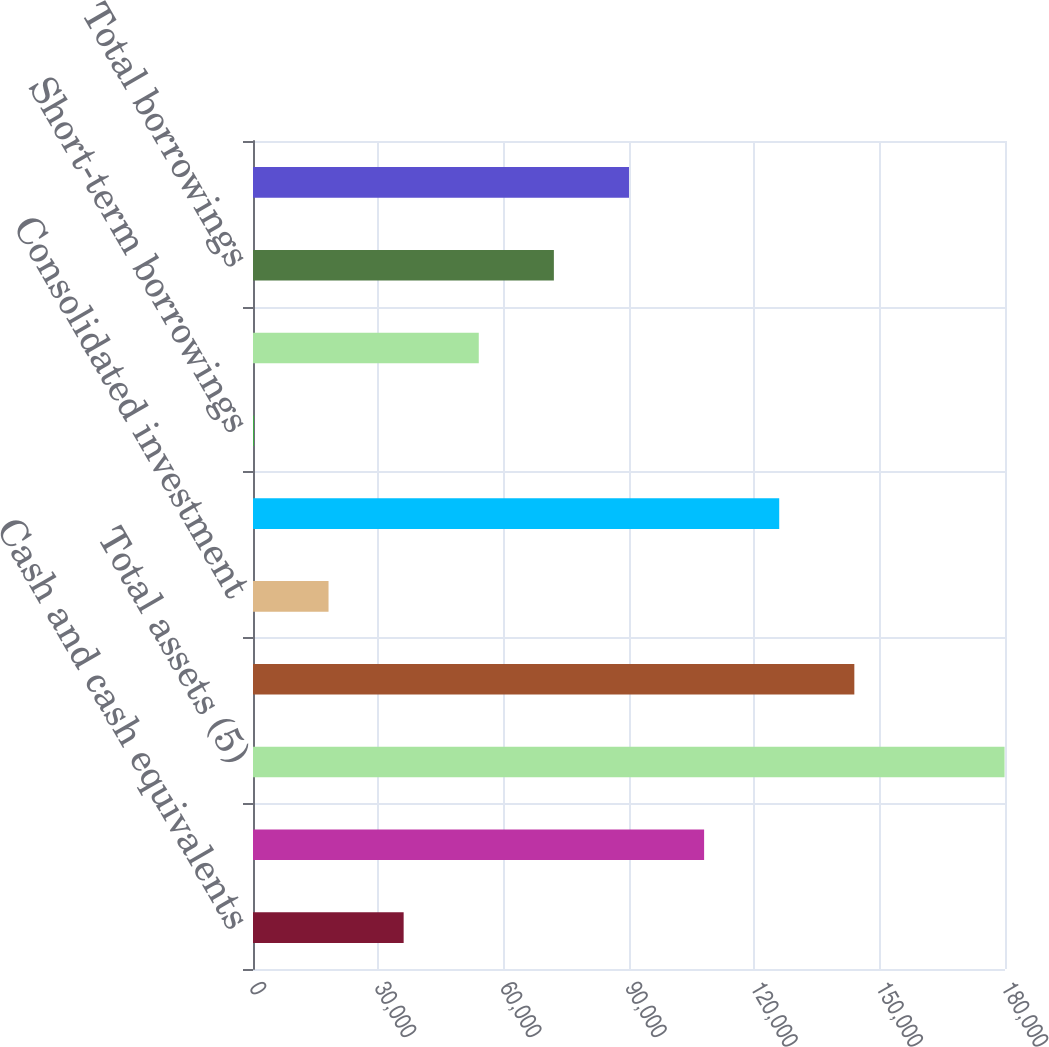<chart> <loc_0><loc_0><loc_500><loc_500><bar_chart><fcel>Cash and cash equivalents<fcel>Goodwill and intangible assets<fcel>Total assets (5)<fcel>Separate account assets (6)<fcel>Consolidated investment<fcel>Adjusted total assets<fcel>Short-term borrowings<fcel>Long-term borrowings<fcel>Total borrowings<fcel>Total stockholders' equity<nl><fcel>36059.2<fcel>107978<fcel>179896<fcel>143937<fcel>18079.6<fcel>125957<fcel>100<fcel>54038.8<fcel>72018.4<fcel>89998<nl></chart> 